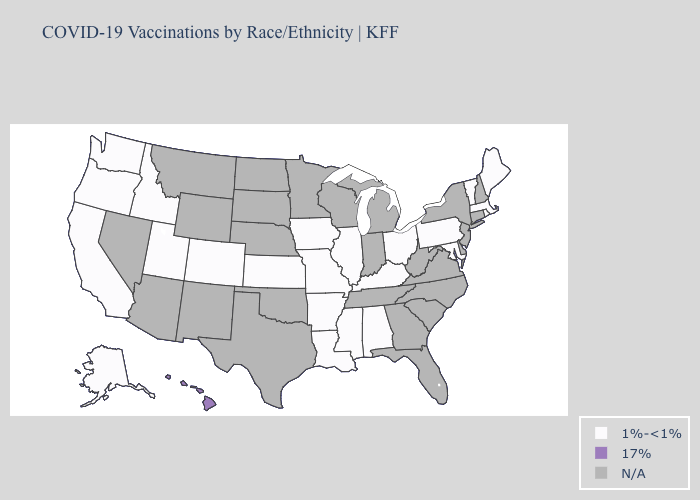Name the states that have a value in the range 17%?
Write a very short answer. Hawaii. What is the value of Ohio?
Write a very short answer. 1%-<1%. What is the highest value in the USA?
Short answer required. 17%. Is the legend a continuous bar?
Quick response, please. No. Does Utah have the highest value in the West?
Short answer required. No. Does Hawaii have the highest value in the West?
Quick response, please. Yes. Does the first symbol in the legend represent the smallest category?
Answer briefly. Yes. Name the states that have a value in the range 1%-<1%?
Give a very brief answer. Alabama, Alaska, Arkansas, California, Colorado, Idaho, Illinois, Iowa, Kansas, Kentucky, Louisiana, Maine, Maryland, Massachusetts, Mississippi, Missouri, Ohio, Oregon, Pennsylvania, Rhode Island, Utah, Vermont, Washington. Does Iowa have the lowest value in the USA?
Give a very brief answer. Yes. What is the value of Kentucky?
Keep it brief. 1%-<1%. 